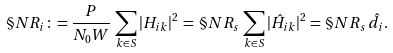<formula> <loc_0><loc_0><loc_500><loc_500>\S N R _ { i } \colon = \frac { P } { N _ { 0 } W } \, \sum _ { k \in S } | H _ { i k } | ^ { 2 } \, = \, \S N R _ { s } \, \sum _ { k \in S } | \hat { H } _ { i k } | ^ { 2 } = \, \S N R _ { s } \, \hat { d } _ { i } .</formula> 